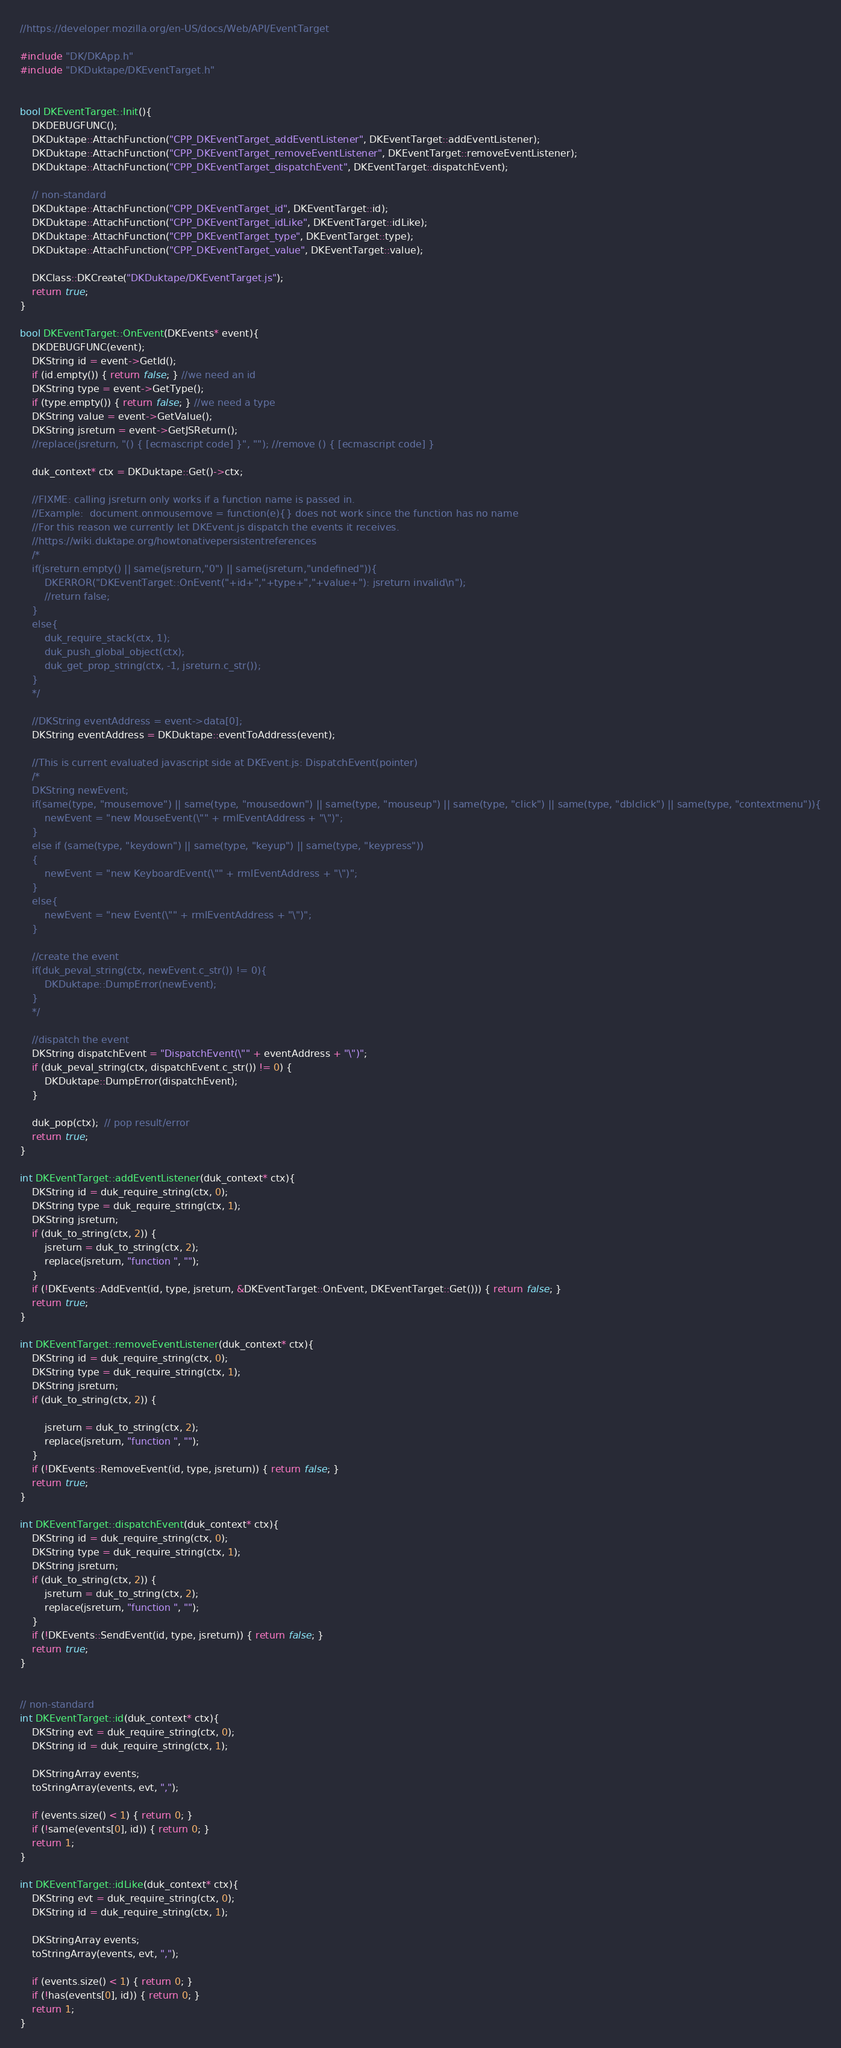<code> <loc_0><loc_0><loc_500><loc_500><_C++_>//https://developer.mozilla.org/en-US/docs/Web/API/EventTarget

#include "DK/DKApp.h"
#include "DKDuktape/DKEventTarget.h"


bool DKEventTarget::Init(){
	DKDEBUGFUNC();
	DKDuktape::AttachFunction("CPP_DKEventTarget_addEventListener", DKEventTarget::addEventListener);
	DKDuktape::AttachFunction("CPP_DKEventTarget_removeEventListener", DKEventTarget::removeEventListener);
	DKDuktape::AttachFunction("CPP_DKEventTarget_dispatchEvent", DKEventTarget::dispatchEvent);

	// non-standard
	DKDuktape::AttachFunction("CPP_DKEventTarget_id", DKEventTarget::id);
	DKDuktape::AttachFunction("CPP_DKEventTarget_idLike", DKEventTarget::idLike);
	DKDuktape::AttachFunction("CPP_DKEventTarget_type", DKEventTarget::type);
	DKDuktape::AttachFunction("CPP_DKEventTarget_value", DKEventTarget::value);

	DKClass::DKCreate("DKDuktape/DKEventTarget.js");
	return true;
}

bool DKEventTarget::OnEvent(DKEvents* event){
	DKDEBUGFUNC(event);
	DKString id = event->GetId();
	if (id.empty()) { return false; } //we need an id
	DKString type = event->GetType();
	if (type.empty()) { return false; } //we need a type
	DKString value = event->GetValue();
	DKString jsreturn = event->GetJSReturn();
	//replace(jsreturn, "() { [ecmascript code] }", ""); //remove () { [ecmascript code] }

	duk_context* ctx = DKDuktape::Get()->ctx;

	//FIXME: calling jsreturn only works if a function name is passed in.
	//Example:  document.onmousemove = function(e){} does not work since the function has no name
	//For this reason we currently let DKEvent.js dispatch the events it receives.
	//https://wiki.duktape.org/howtonativepersistentreferences
	/*
	if(jsreturn.empty() || same(jsreturn,"0") || same(jsreturn,"undefined")){
		DKERROR("DKEventTarget::OnEvent("+id+","+type+","+value+"): jsreturn invalid\n");
		//return false;
	}
	else{
		duk_require_stack(ctx, 1);
		duk_push_global_object(ctx);
		duk_get_prop_string(ctx, -1, jsreturn.c_str());
	}
	*/

	//DKString eventAddress = event->data[0];
	DKString eventAddress = DKDuktape::eventToAddress(event);

	//This is current evaluated javascript side at DKEvent.js: DispatchEvent(pointer)
	/*
	DKString newEvent;
	if(same(type, "mousemove") || same(type, "mousedown") || same(type, "mouseup") || same(type, "click") || same(type, "dblclick") || same(type, "contextmenu")){
		newEvent = "new MouseEvent(\"" + rmlEventAddress + "\")";
	}
	else if (same(type, "keydown") || same(type, "keyup") || same(type, "keypress"))
	{
		newEvent = "new KeyboardEvent(\"" + rmlEventAddress + "\")";
	}
	else{
		newEvent = "new Event(\"" + rmlEventAddress + "\")";
	}

	//create the event
	if(duk_peval_string(ctx, newEvent.c_str()) != 0){
		DKDuktape::DumpError(newEvent);
	}
	*/

	//dispatch the event
	DKString dispatchEvent = "DispatchEvent(\"" + eventAddress + "\")";
	if (duk_peval_string(ctx, dispatchEvent.c_str()) != 0) {
		DKDuktape::DumpError(dispatchEvent);
	}

	duk_pop(ctx);  // pop result/error
	return true;
}

int DKEventTarget::addEventListener(duk_context* ctx){
	DKString id = duk_require_string(ctx, 0);
	DKString type = duk_require_string(ctx, 1);
	DKString jsreturn;
	if (duk_to_string(ctx, 2)) {
		jsreturn = duk_to_string(ctx, 2);
		replace(jsreturn, "function ", "");
	}
	if (!DKEvents::AddEvent(id, type, jsreturn, &DKEventTarget::OnEvent, DKEventTarget::Get())) { return false; }
	return true;
}

int DKEventTarget::removeEventListener(duk_context* ctx){
	DKString id = duk_require_string(ctx, 0);
	DKString type = duk_require_string(ctx, 1);
	DKString jsreturn;
	if (duk_to_string(ctx, 2)) {

		jsreturn = duk_to_string(ctx, 2);
		replace(jsreturn, "function ", "");
	}
	if (!DKEvents::RemoveEvent(id, type, jsreturn)) { return false; }
	return true;
}

int DKEventTarget::dispatchEvent(duk_context* ctx){
	DKString id = duk_require_string(ctx, 0);
	DKString type = duk_require_string(ctx, 1);
	DKString jsreturn;
	if (duk_to_string(ctx, 2)) {
		jsreturn = duk_to_string(ctx, 2);
		replace(jsreturn, "function ", "");
	}
	if (!DKEvents::SendEvent(id, type, jsreturn)) { return false; }
	return true;
}


// non-standard
int DKEventTarget::id(duk_context* ctx){
	DKString evt = duk_require_string(ctx, 0);
	DKString id = duk_require_string(ctx, 1);

	DKStringArray events;
	toStringArray(events, evt, ",");

	if (events.size() < 1) { return 0; }
	if (!same(events[0], id)) { return 0; }
	return 1;
}

int DKEventTarget::idLike(duk_context* ctx){
	DKString evt = duk_require_string(ctx, 0);
	DKString id = duk_require_string(ctx, 1);

	DKStringArray events;
	toStringArray(events, evt, ",");

	if (events.size() < 1) { return 0; }
	if (!has(events[0], id)) { return 0; }
	return 1;
}
</code> 